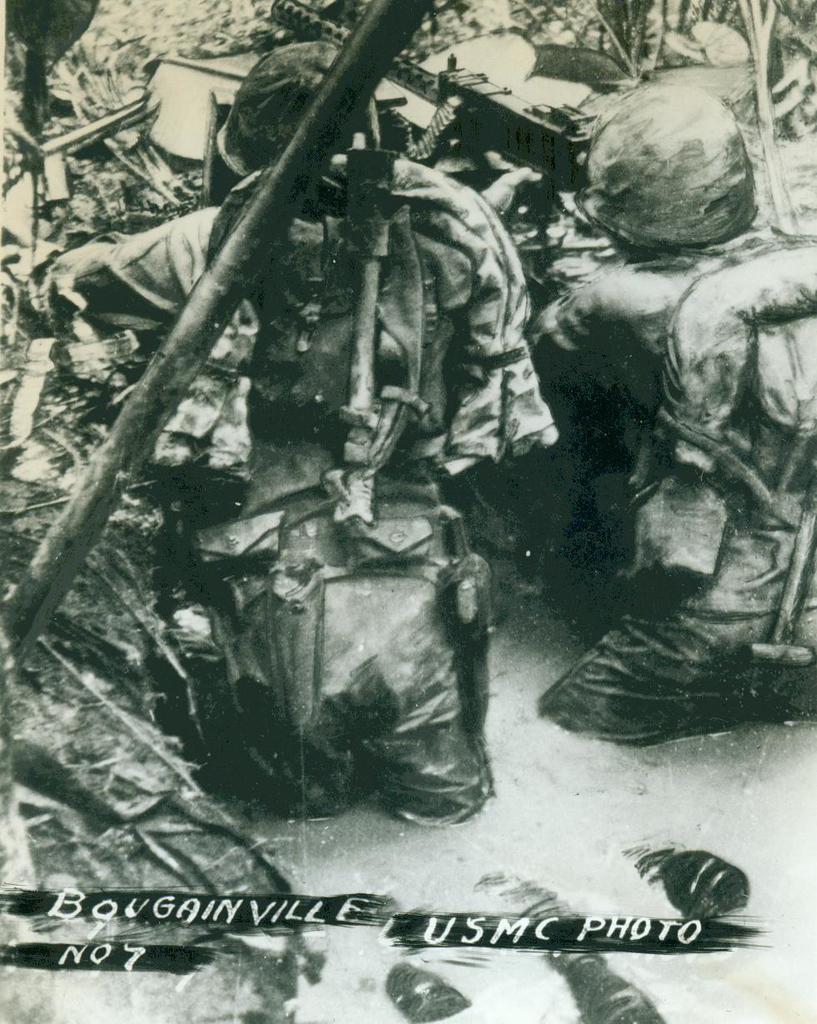Describe this image in one or two sentences. In this image we can see some persons hiding behind someone blocks, wearing helmets, carrying bags, holding weapons in their hands and at the bottom of the image there is water. 